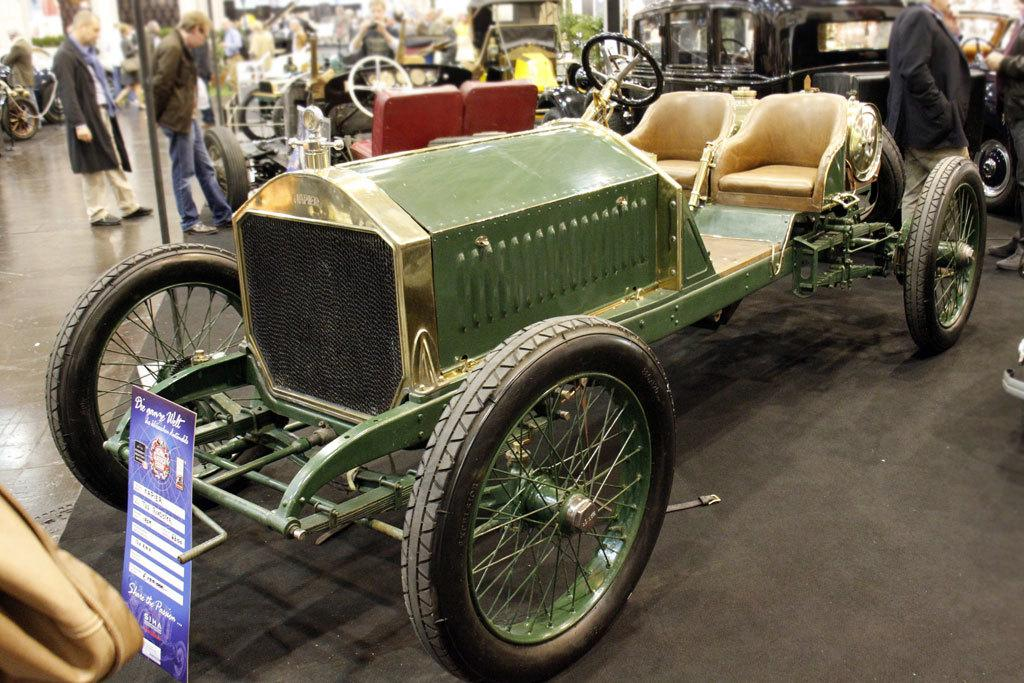What type of event is the image from? The image is from a vehicle expo. What can be seen in the room during the event? There are multiple vehicles in the room. Are there any people present at the event? Yes, people are present in the room. What are the people doing at the event? The people are watching the vehicles and some of them are taking photographs. What type of stomach can be seen in the image? There is no stomach visible in the image. The image is from a vehicle expo, and there are no stomachs mentioned or visible in the image. 